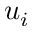<formula> <loc_0><loc_0><loc_500><loc_500>u _ { i }</formula> 